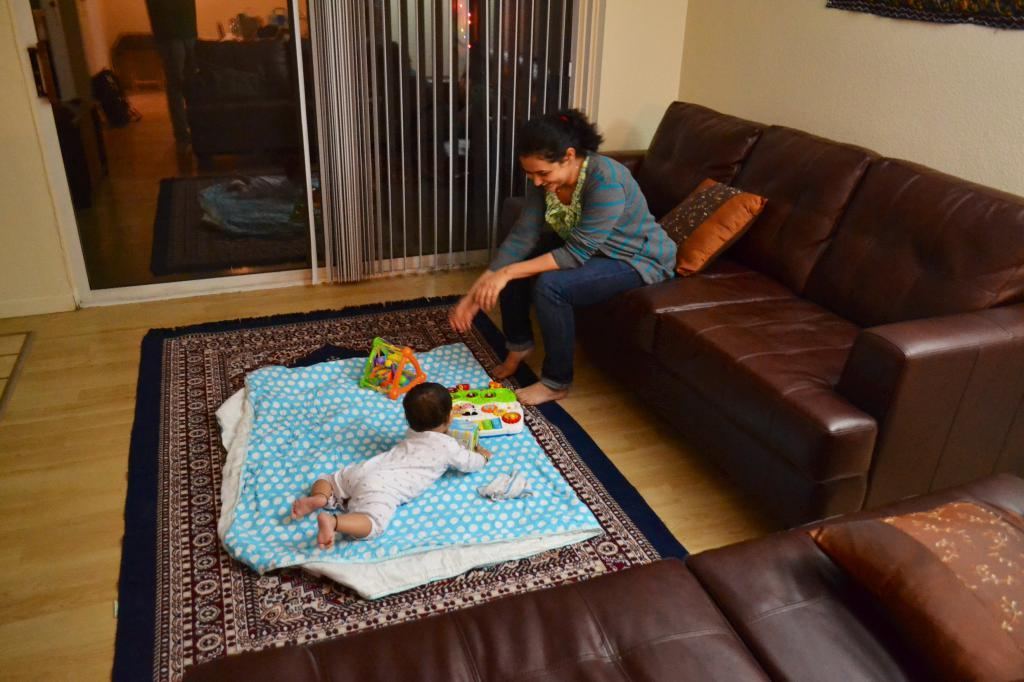Who is the main subject in the image? There is a woman in the image. What is the woman doing in the image? The woman is seated on a sofa and smiling. Are there any other people or living beings in the image? Yes, there is a baby in the image. What is the baby doing in the image? The baby is playing with toys. What type of marble is the baby using to play with the toys in the image? There is no marble present in the image; the baby is playing with toys. 